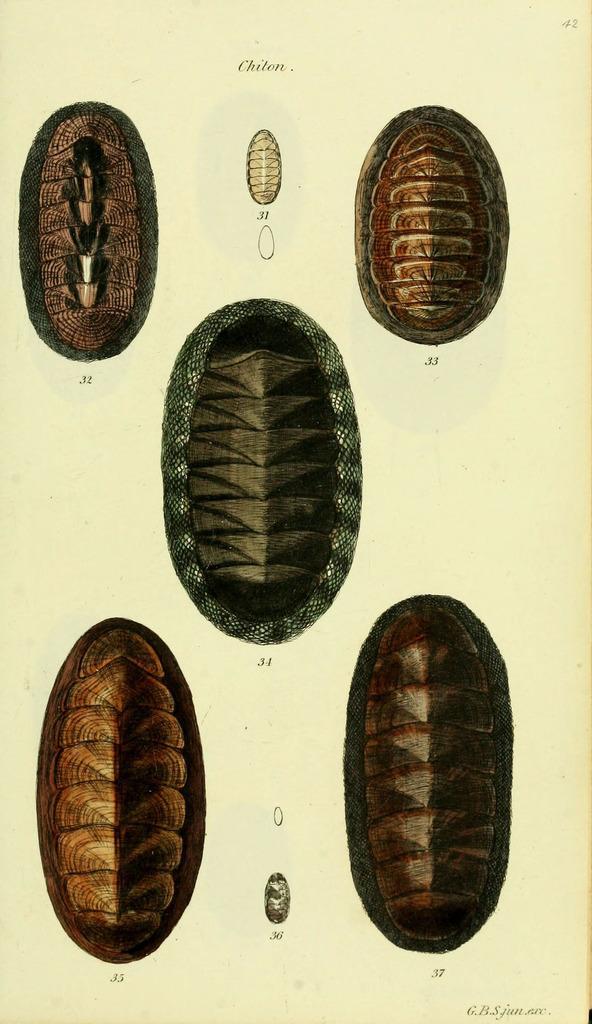Could you give a brief overview of what you see in this image? In this picture we can see a few shells of cockroaches. 